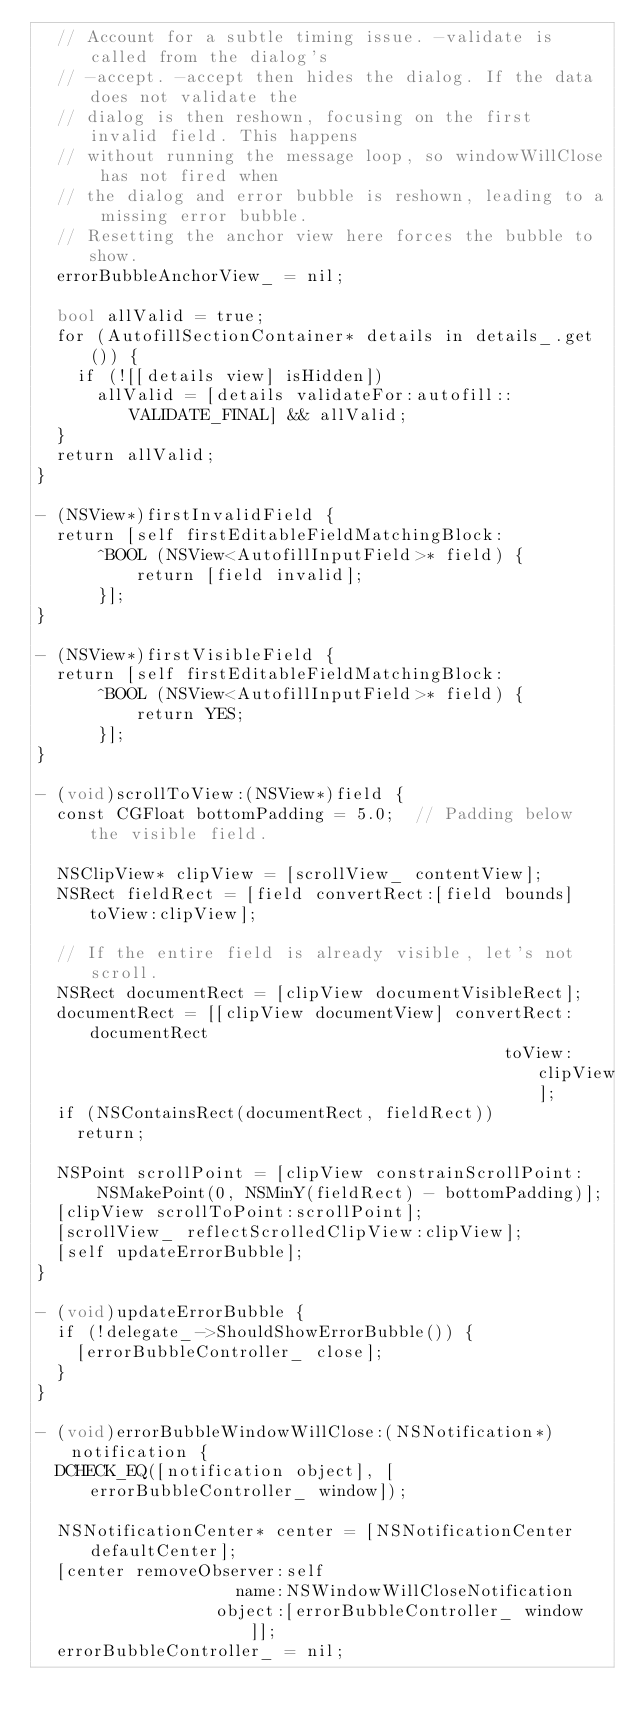Convert code to text. <code><loc_0><loc_0><loc_500><loc_500><_ObjectiveC_>  // Account for a subtle timing issue. -validate is called from the dialog's
  // -accept. -accept then hides the dialog. If the data does not validate the
  // dialog is then reshown, focusing on the first invalid field. This happens
  // without running the message loop, so windowWillClose has not fired when
  // the dialog and error bubble is reshown, leading to a missing error bubble.
  // Resetting the anchor view here forces the bubble to show.
  errorBubbleAnchorView_ = nil;

  bool allValid = true;
  for (AutofillSectionContainer* details in details_.get()) {
    if (![[details view] isHidden])
      allValid = [details validateFor:autofill::VALIDATE_FINAL] && allValid;
  }
  return allValid;
}

- (NSView*)firstInvalidField {
  return [self firstEditableFieldMatchingBlock:
      ^BOOL (NSView<AutofillInputField>* field) {
          return [field invalid];
      }];
}

- (NSView*)firstVisibleField {
  return [self firstEditableFieldMatchingBlock:
      ^BOOL (NSView<AutofillInputField>* field) {
          return YES;
      }];
}

- (void)scrollToView:(NSView*)field {
  const CGFloat bottomPadding = 5.0;  // Padding below the visible field.

  NSClipView* clipView = [scrollView_ contentView];
  NSRect fieldRect = [field convertRect:[field bounds] toView:clipView];

  // If the entire field is already visible, let's not scroll.
  NSRect documentRect = [clipView documentVisibleRect];
  documentRect = [[clipView documentView] convertRect:documentRect
                                               toView:clipView];
  if (NSContainsRect(documentRect, fieldRect))
    return;

  NSPoint scrollPoint = [clipView constrainScrollPoint:
      NSMakePoint(0, NSMinY(fieldRect) - bottomPadding)];
  [clipView scrollToPoint:scrollPoint];
  [scrollView_ reflectScrolledClipView:clipView];
  [self updateErrorBubble];
}

- (void)updateErrorBubble {
  if (!delegate_->ShouldShowErrorBubble()) {
    [errorBubbleController_ close];
  }
}

- (void)errorBubbleWindowWillClose:(NSNotification*)notification {
  DCHECK_EQ([notification object], [errorBubbleController_ window]);

  NSNotificationCenter* center = [NSNotificationCenter defaultCenter];
  [center removeObserver:self
                    name:NSWindowWillCloseNotification
                  object:[errorBubbleController_ window]];
  errorBubbleController_ = nil;</code> 